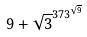<formula> <loc_0><loc_0><loc_500><loc_500>9 + \sqrt { 3 } ^ { 3 7 3 ^ { \sqrt { 9 } } }</formula> 